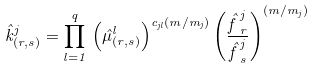Convert formula to latex. <formula><loc_0><loc_0><loc_500><loc_500>\hat { k } ^ { j } _ { ( r , s ) } = \prod _ { l = 1 } ^ { q } \, \left ( \hat { \mu } ^ { l } _ { ( r , s ) } \right ) ^ { c _ { j l } ( m / m _ { j } ) } \left ( \frac { \hat { f \, } ^ { j } _ { r } } { \hat { f \, } ^ { j } _ { s } } \right ) ^ { ( m / m _ { j } ) }</formula> 